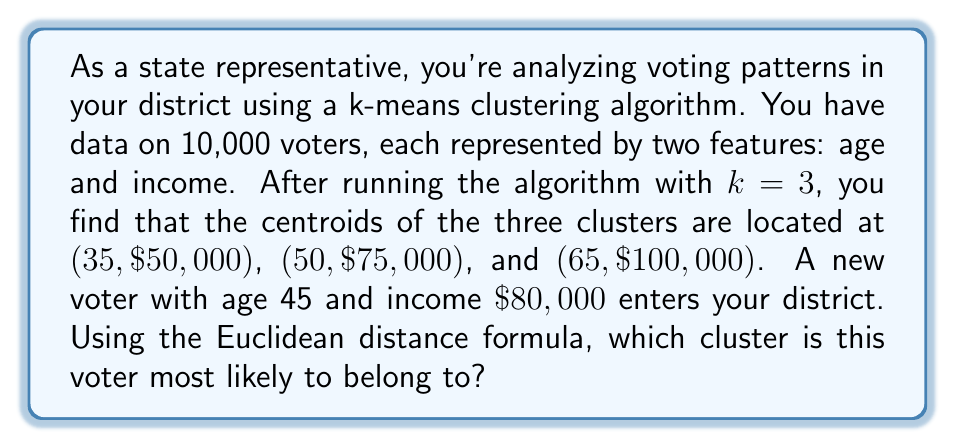Help me with this question. To solve this problem, we need to calculate the Euclidean distance between the new voter and each of the three cluster centroids. The voter will belong to the cluster with the smallest distance.

The Euclidean distance formula in two dimensions is:

$$d = \sqrt{(x_2 - x_1)^2 + (y_2 - y_1)^2}$$

Where $(x_1, y_1)$ is the position of the new voter and $(x_2, y_2)$ is the position of each centroid.

Let's calculate the distance to each centroid:

1. Distance to centroid 1 (35, $50,000):
   $$d_1 = \sqrt{(45 - 35)^2 + (80000 - 50000)^2} = \sqrt{100 + 900000000} = 30000.17$$

2. Distance to centroid 2 (50, $75,000):
   $$d_2 = \sqrt{(45 - 50)^2 + (80000 - 75000)^2} = \sqrt{25 + 25000000} = 5000.02$$

3. Distance to centroid 3 (65, $100,000):
   $$d_3 = \sqrt{(45 - 65)^2 + (80000 - 100000)^2} = \sqrt{400 + 400000000} = 20000.10$$

The smallest distance is $d_2 = 5000.02$, which corresponds to the second centroid (50, $75,000).
Answer: The new voter is most likely to belong to the cluster with centroid (50, $75,000). 